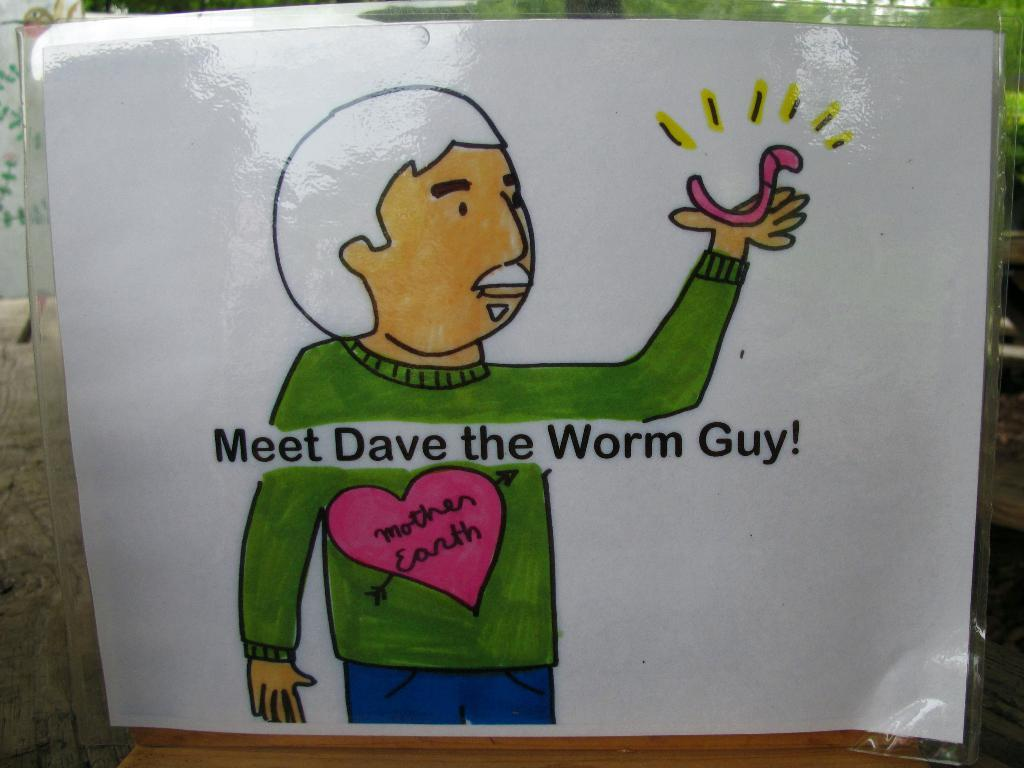What is the main subject of the image? The main subject of the image is a sketch of a person. What can be seen on the sketch besides the person? There is text written on the sketch. What type of ornament is hanging from the person's jeans in the image? There is no person, sketch, or jeans present in the image, so there is no ornament to describe. 